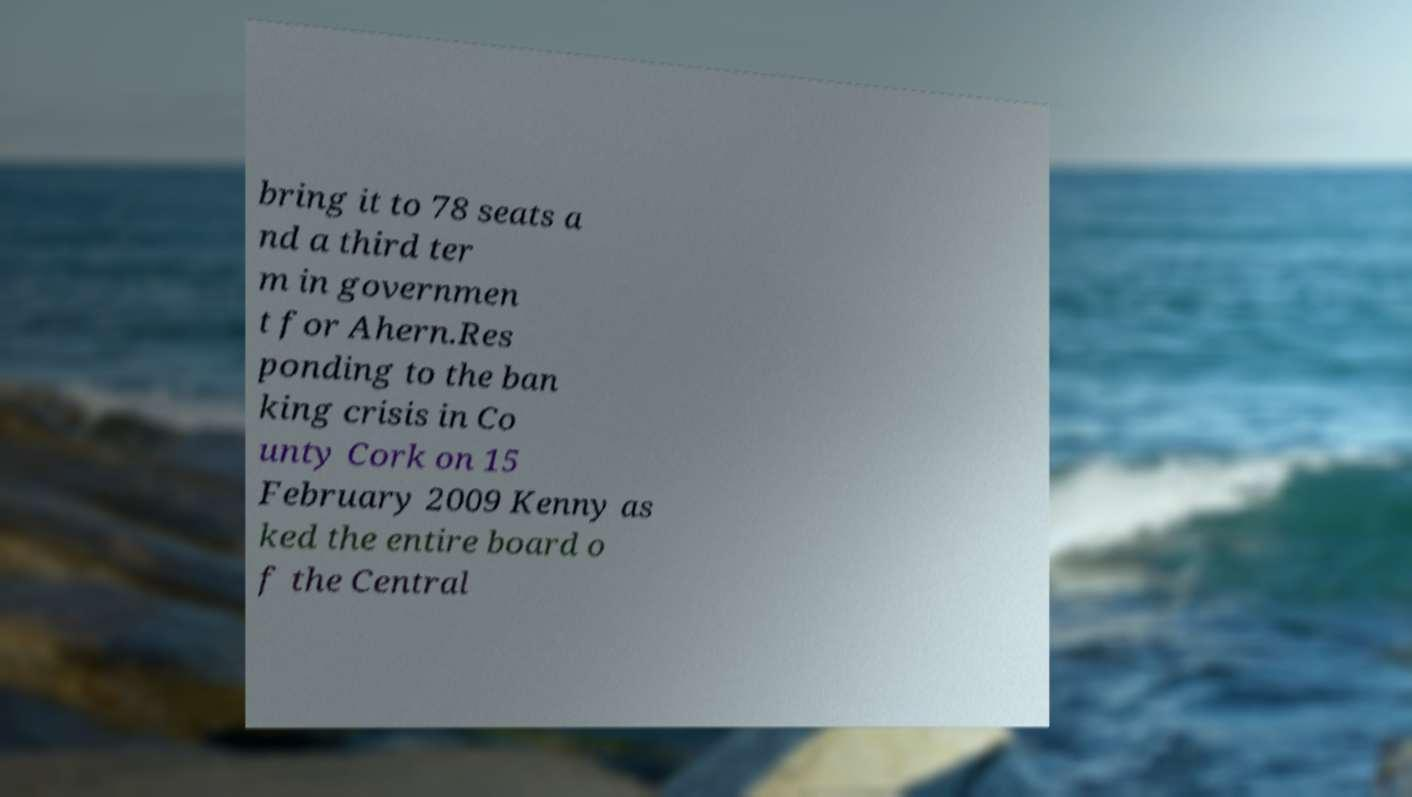Can you read and provide the text displayed in the image?This photo seems to have some interesting text. Can you extract and type it out for me? bring it to 78 seats a nd a third ter m in governmen t for Ahern.Res ponding to the ban king crisis in Co unty Cork on 15 February 2009 Kenny as ked the entire board o f the Central 